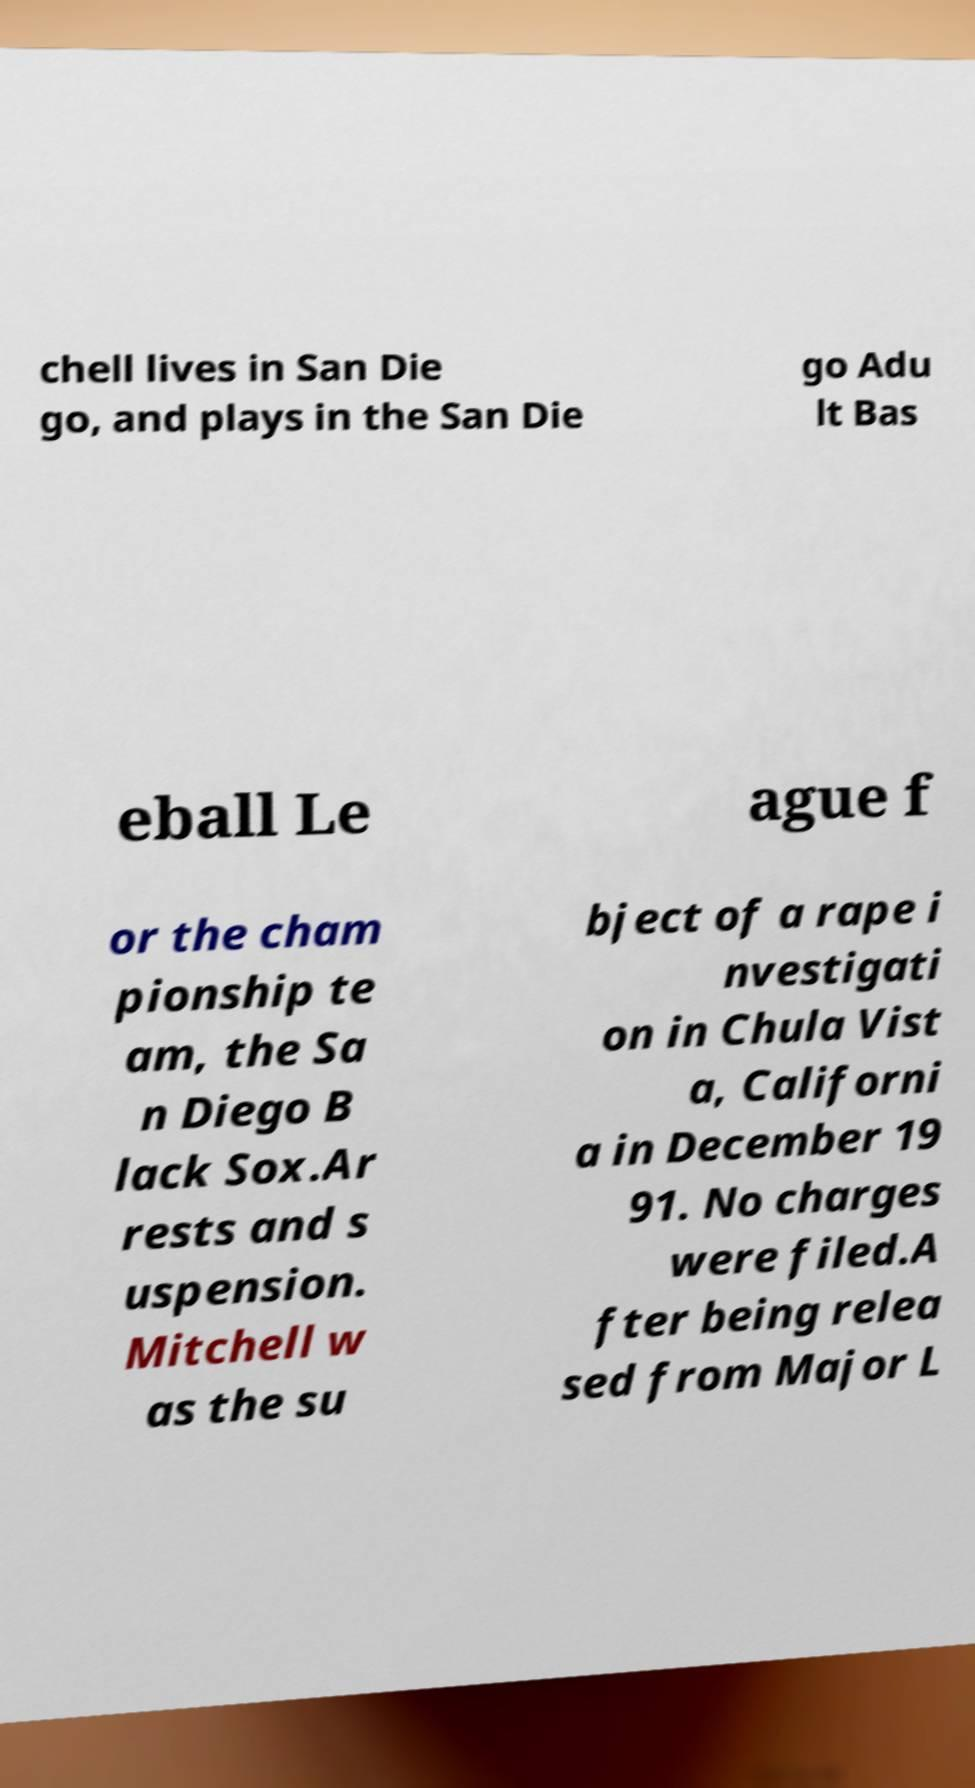Please identify and transcribe the text found in this image. chell lives in San Die go, and plays in the San Die go Adu lt Bas eball Le ague f or the cham pionship te am, the Sa n Diego B lack Sox.Ar rests and s uspension. Mitchell w as the su bject of a rape i nvestigati on in Chula Vist a, Californi a in December 19 91. No charges were filed.A fter being relea sed from Major L 